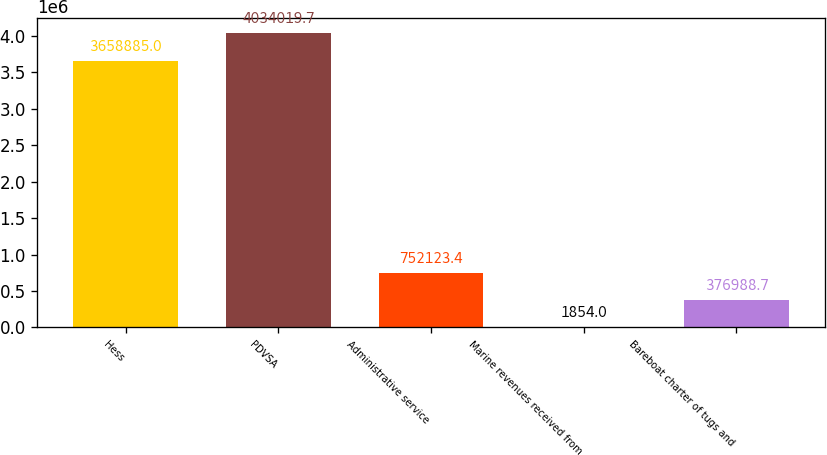Convert chart to OTSL. <chart><loc_0><loc_0><loc_500><loc_500><bar_chart><fcel>Hess<fcel>PDVSA<fcel>Administrative service<fcel>Marine revenues received from<fcel>Bareboat charter of tugs and<nl><fcel>3.65888e+06<fcel>4.03402e+06<fcel>752123<fcel>1854<fcel>376989<nl></chart> 